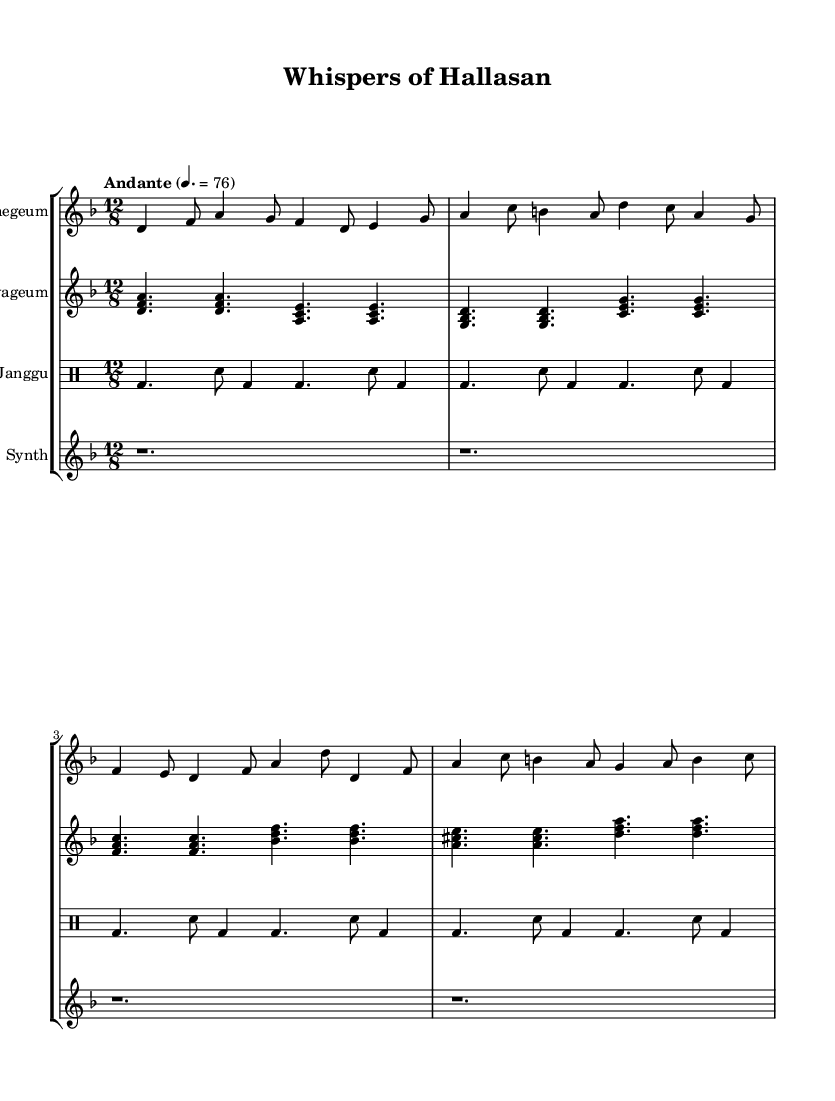What is the key signature of this music? The key signature is D minor, which has one flat (B flat).
Answer: D minor What is the time signature of this music? The time signature is 12/8, indicating a compound meter with four beats per measure, with each beat divided into three eighth notes.
Answer: 12/8 What is the tempo marking given in the sheet music? The tempo marking is Andante, which suggests a moderately slow pace, with a metronome marking of 76 beats per minute.
Answer: Andante How many instruments are featured in this piece? There are four instruments represented: Daegeum, Gayageum, Janggu, and Synthesizer.
Answer: Four What main genre does this piece represent? This piece represents a fusion genre combining Korean traditional music elements with ambient sounds reflective of Jeju Island.
Answer: Fusion What rhythmic pattern is primarily used by the Janggu? The Janggu predominantly uses a pattern of bass (bd) and snare (sn) hits, showcasing variations across the measures.
Answer: bd and sn What harmony is suggested by the Gayageum part? The Gayageum part suggests a series of major and minor chords, indicating harmonic richness and depth typical of Korean traditional music.
Answer: Major and Minor 